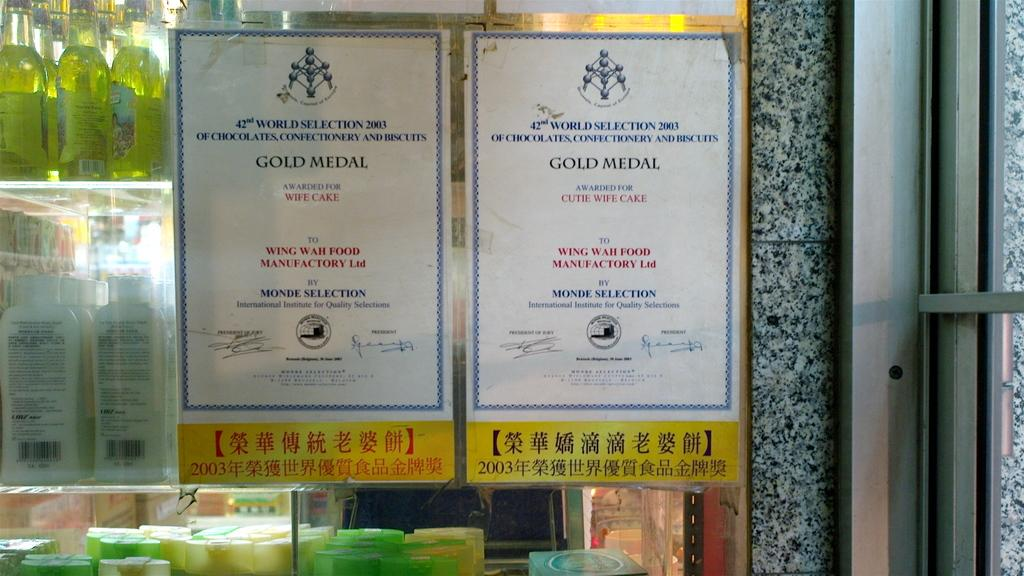<image>
Render a clear and concise summary of the photo. Two signs are on a window that say Gold Metal. 